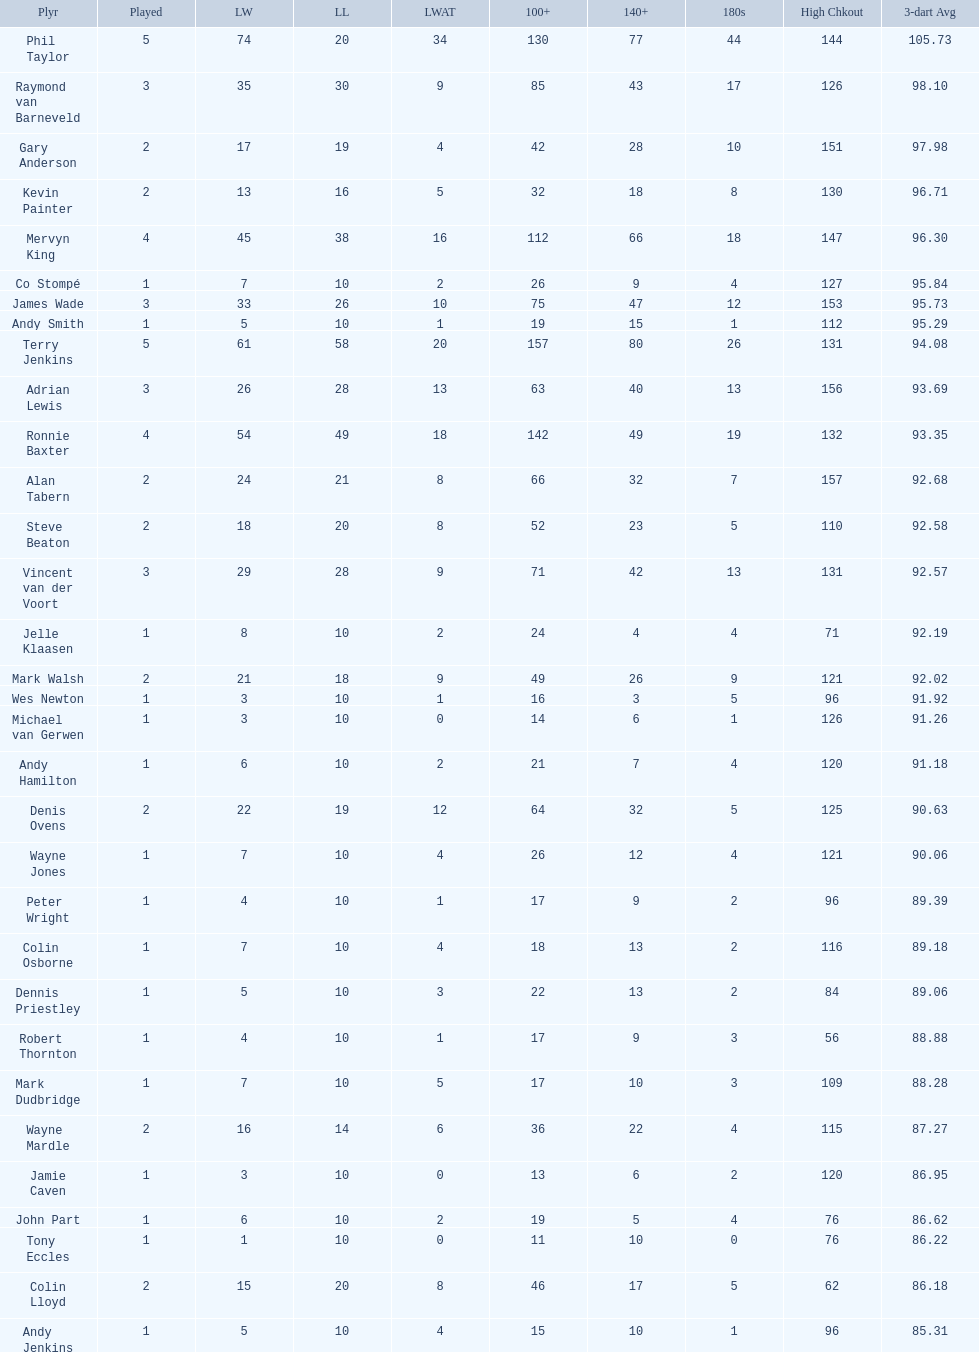Which player lost the least? Co Stompé, Andy Smith, Jelle Klaasen, Wes Newton, Michael van Gerwen, Andy Hamilton, Wayne Jones, Peter Wright, Colin Osborne, Dennis Priestley, Robert Thornton, Mark Dudbridge, Jamie Caven, John Part, Tony Eccles, Andy Jenkins. 